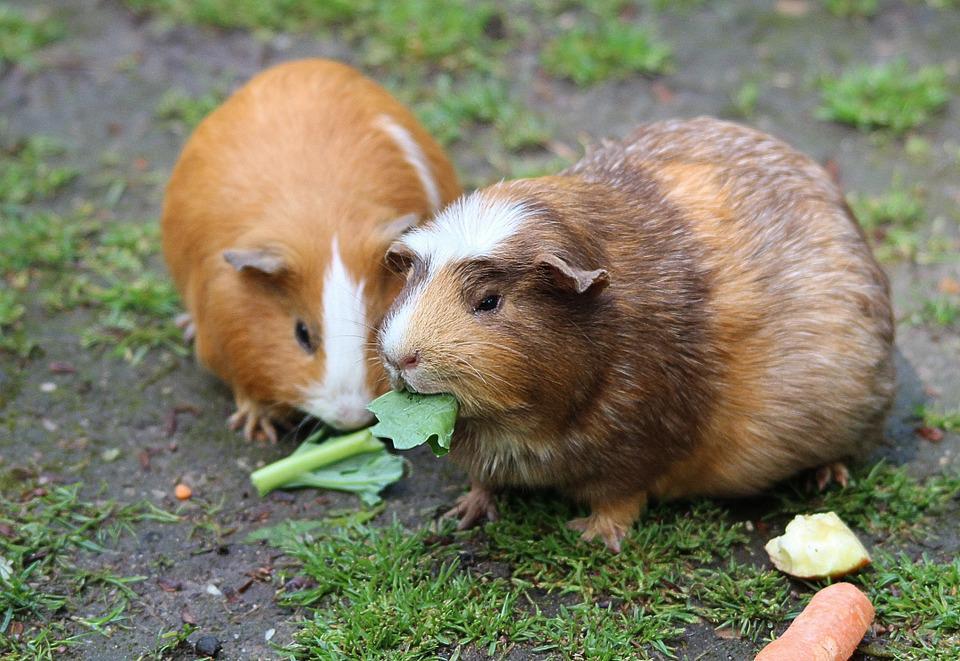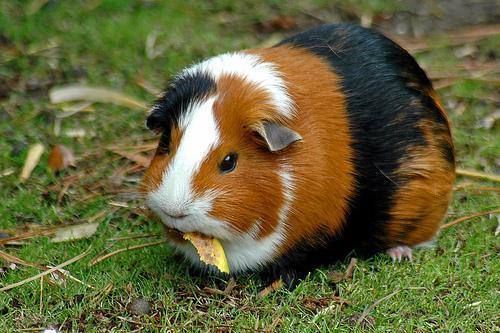The first image is the image on the left, the second image is the image on the right. Considering the images on both sides, is "There are two hamsters." valid? Answer yes or no. No. 